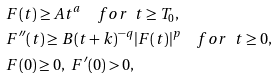<formula> <loc_0><loc_0><loc_500><loc_500>& F ( t ) \geq A t ^ { a } \quad f o r \ \ t \geq T _ { 0 } , \\ & F ^ { \prime \prime } ( t ) \geq B ( t + k ) ^ { - q } | F ( t ) | ^ { p } \quad f o r \ \ t \geq 0 , \\ & F ( 0 ) \geq 0 , \ F ^ { \prime } ( 0 ) > 0 ,</formula> 